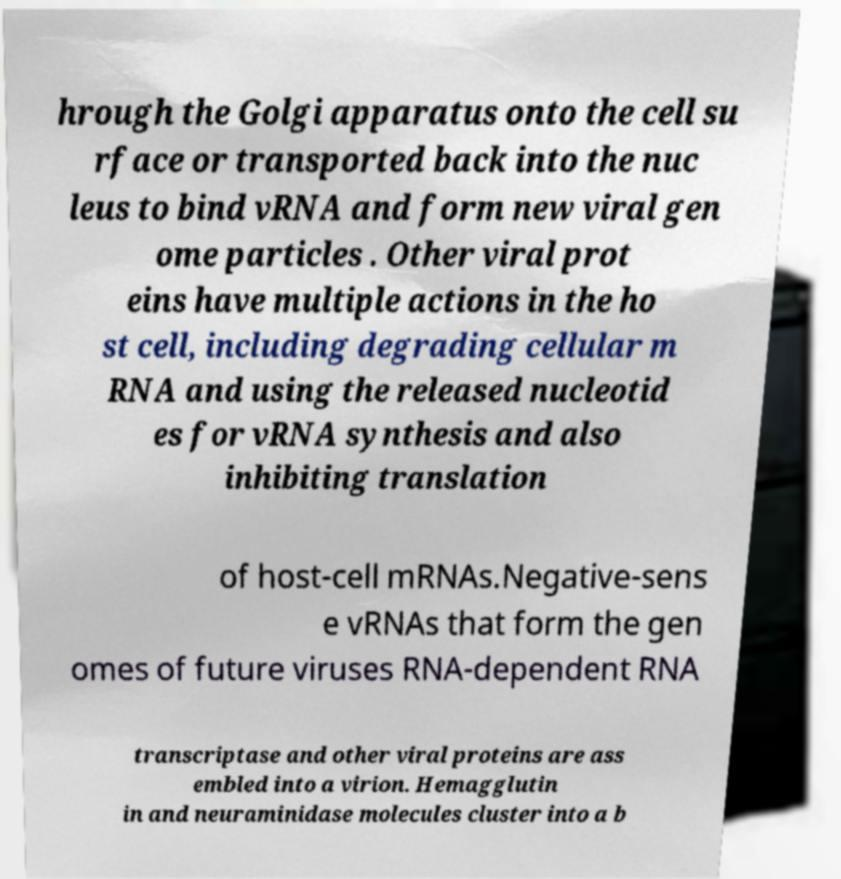Please read and relay the text visible in this image. What does it say? hrough the Golgi apparatus onto the cell su rface or transported back into the nuc leus to bind vRNA and form new viral gen ome particles . Other viral prot eins have multiple actions in the ho st cell, including degrading cellular m RNA and using the released nucleotid es for vRNA synthesis and also inhibiting translation of host-cell mRNAs.Negative-sens e vRNAs that form the gen omes of future viruses RNA-dependent RNA transcriptase and other viral proteins are ass embled into a virion. Hemagglutin in and neuraminidase molecules cluster into a b 